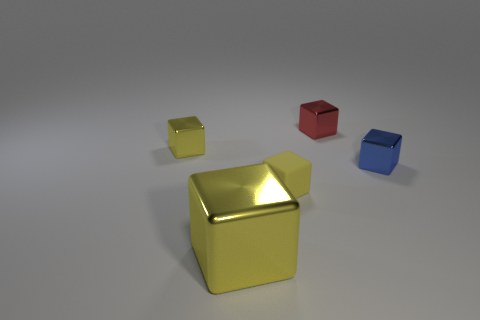There is a rubber thing that is the same size as the red block; what color is it?
Ensure brevity in your answer.  Yellow. Does the tiny red block have the same material as the large yellow block in front of the tiny yellow shiny block?
Give a very brief answer. Yes. How many other things are the same size as the red metal thing?
Your response must be concise. 3. Are there any yellow things behind the object that is in front of the yellow rubber thing in front of the blue metallic block?
Make the answer very short. Yes. What is the size of the yellow metallic thing that is behind the yellow matte cube?
Give a very brief answer. Small. Do the yellow shiny thing behind the blue object and the blue thing have the same size?
Your answer should be very brief. Yes. Is there any other thing that has the same color as the big metal object?
Your response must be concise. Yes. There is a blue metallic thing; what shape is it?
Offer a very short reply. Cube. How many blocks are both to the left of the blue object and behind the large yellow metal block?
Keep it short and to the point. 3. Is the color of the large thing the same as the matte cube?
Keep it short and to the point. Yes. 